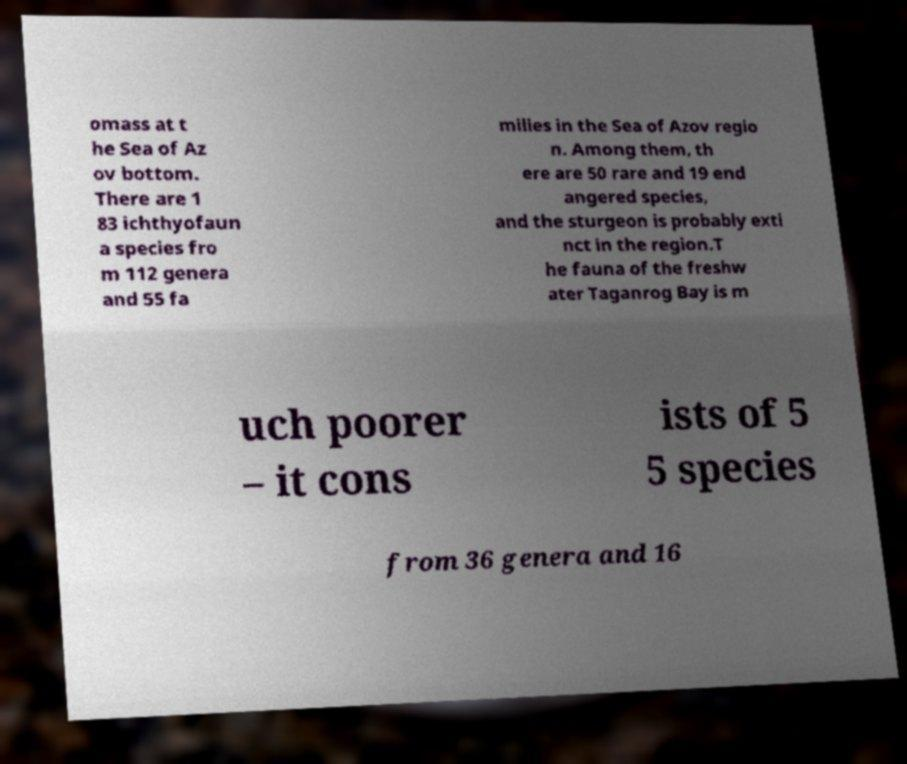Can you accurately transcribe the text from the provided image for me? omass at t he Sea of Az ov bottom. There are 1 83 ichthyofaun a species fro m 112 genera and 55 fa milies in the Sea of Azov regio n. Among them, th ere are 50 rare and 19 end angered species, and the sturgeon is probably exti nct in the region.T he fauna of the freshw ater Taganrog Bay is m uch poorer – it cons ists of 5 5 species from 36 genera and 16 